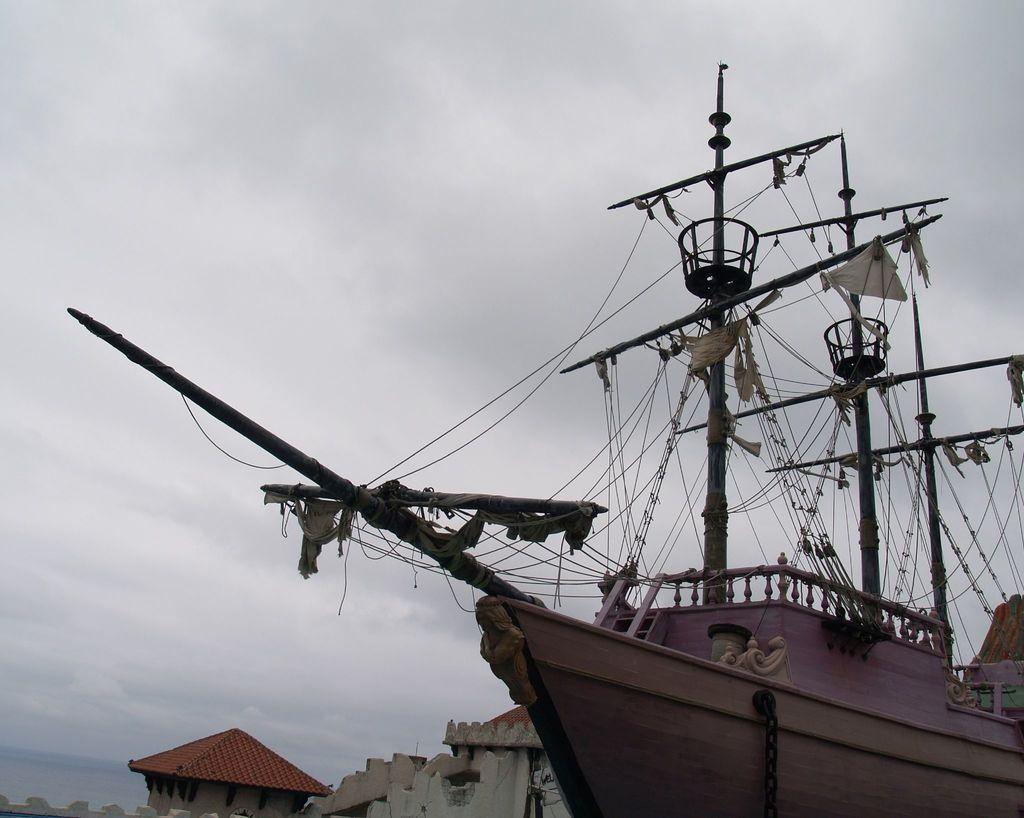What is located on the right side of the image? There is a ship on the right side of the image. What items can be seen inside the ship? There are bags and ropes in the ship. What can be seen in the background of the image? There are buildings and a beach in the background of the image. What is visible at the top of the image? The sky is visible at the top of the image. What type of band is playing on the beach in the image? There is no band playing on the beach in the image; it only shows a ship with bags and ropes, buildings in the background, and a beach. Can you see any snakes in the image? There are no snakes visible in the image. 